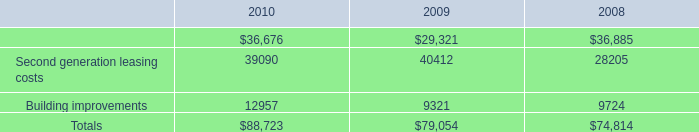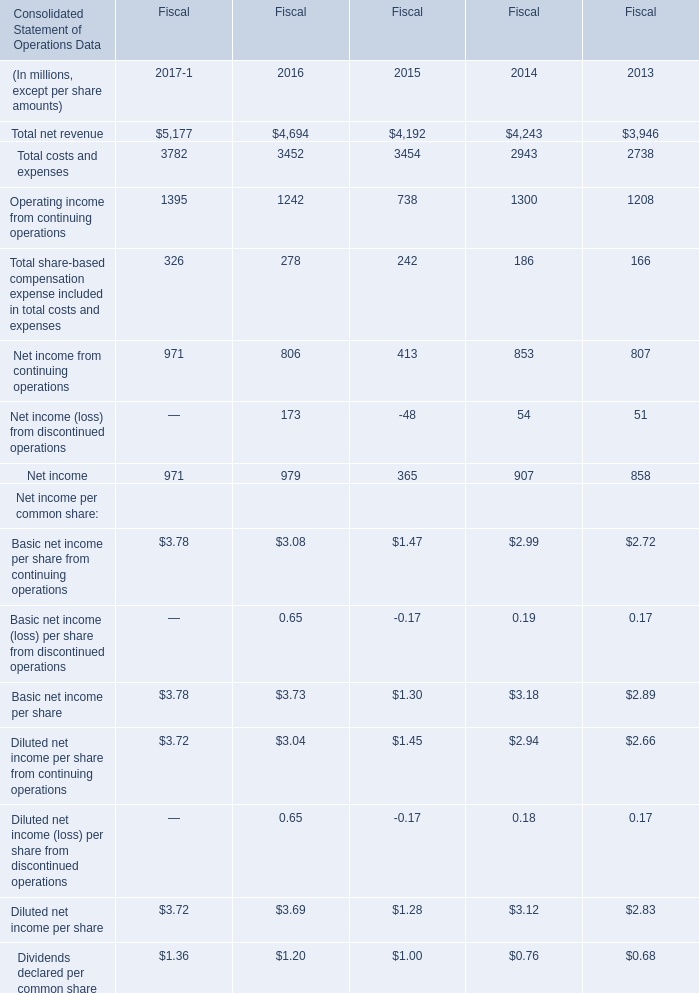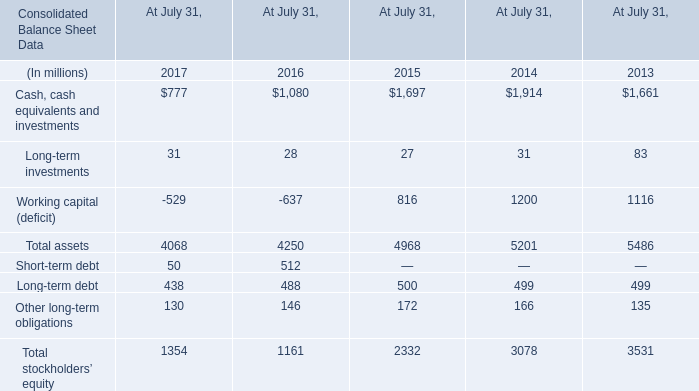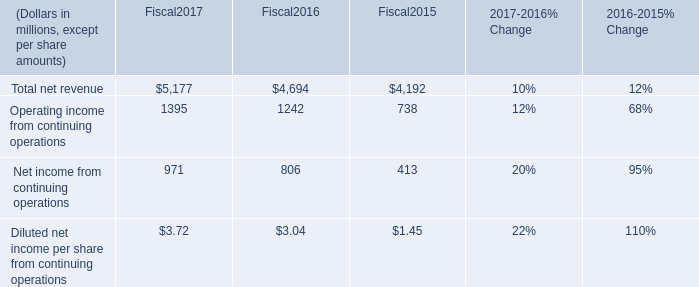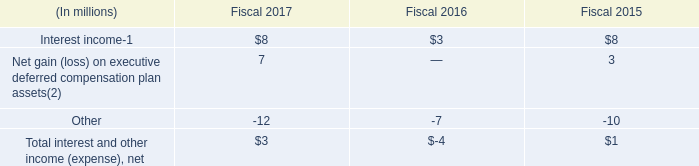What is the total amount of Cash, cash equivalents and investments of At July 31, 2013, Building improvements of 2009, and Total net revenue of Fiscal2015 ? 
Computations: ((1661.0 + 9321.0) + 4192.0)
Answer: 15174.0. 